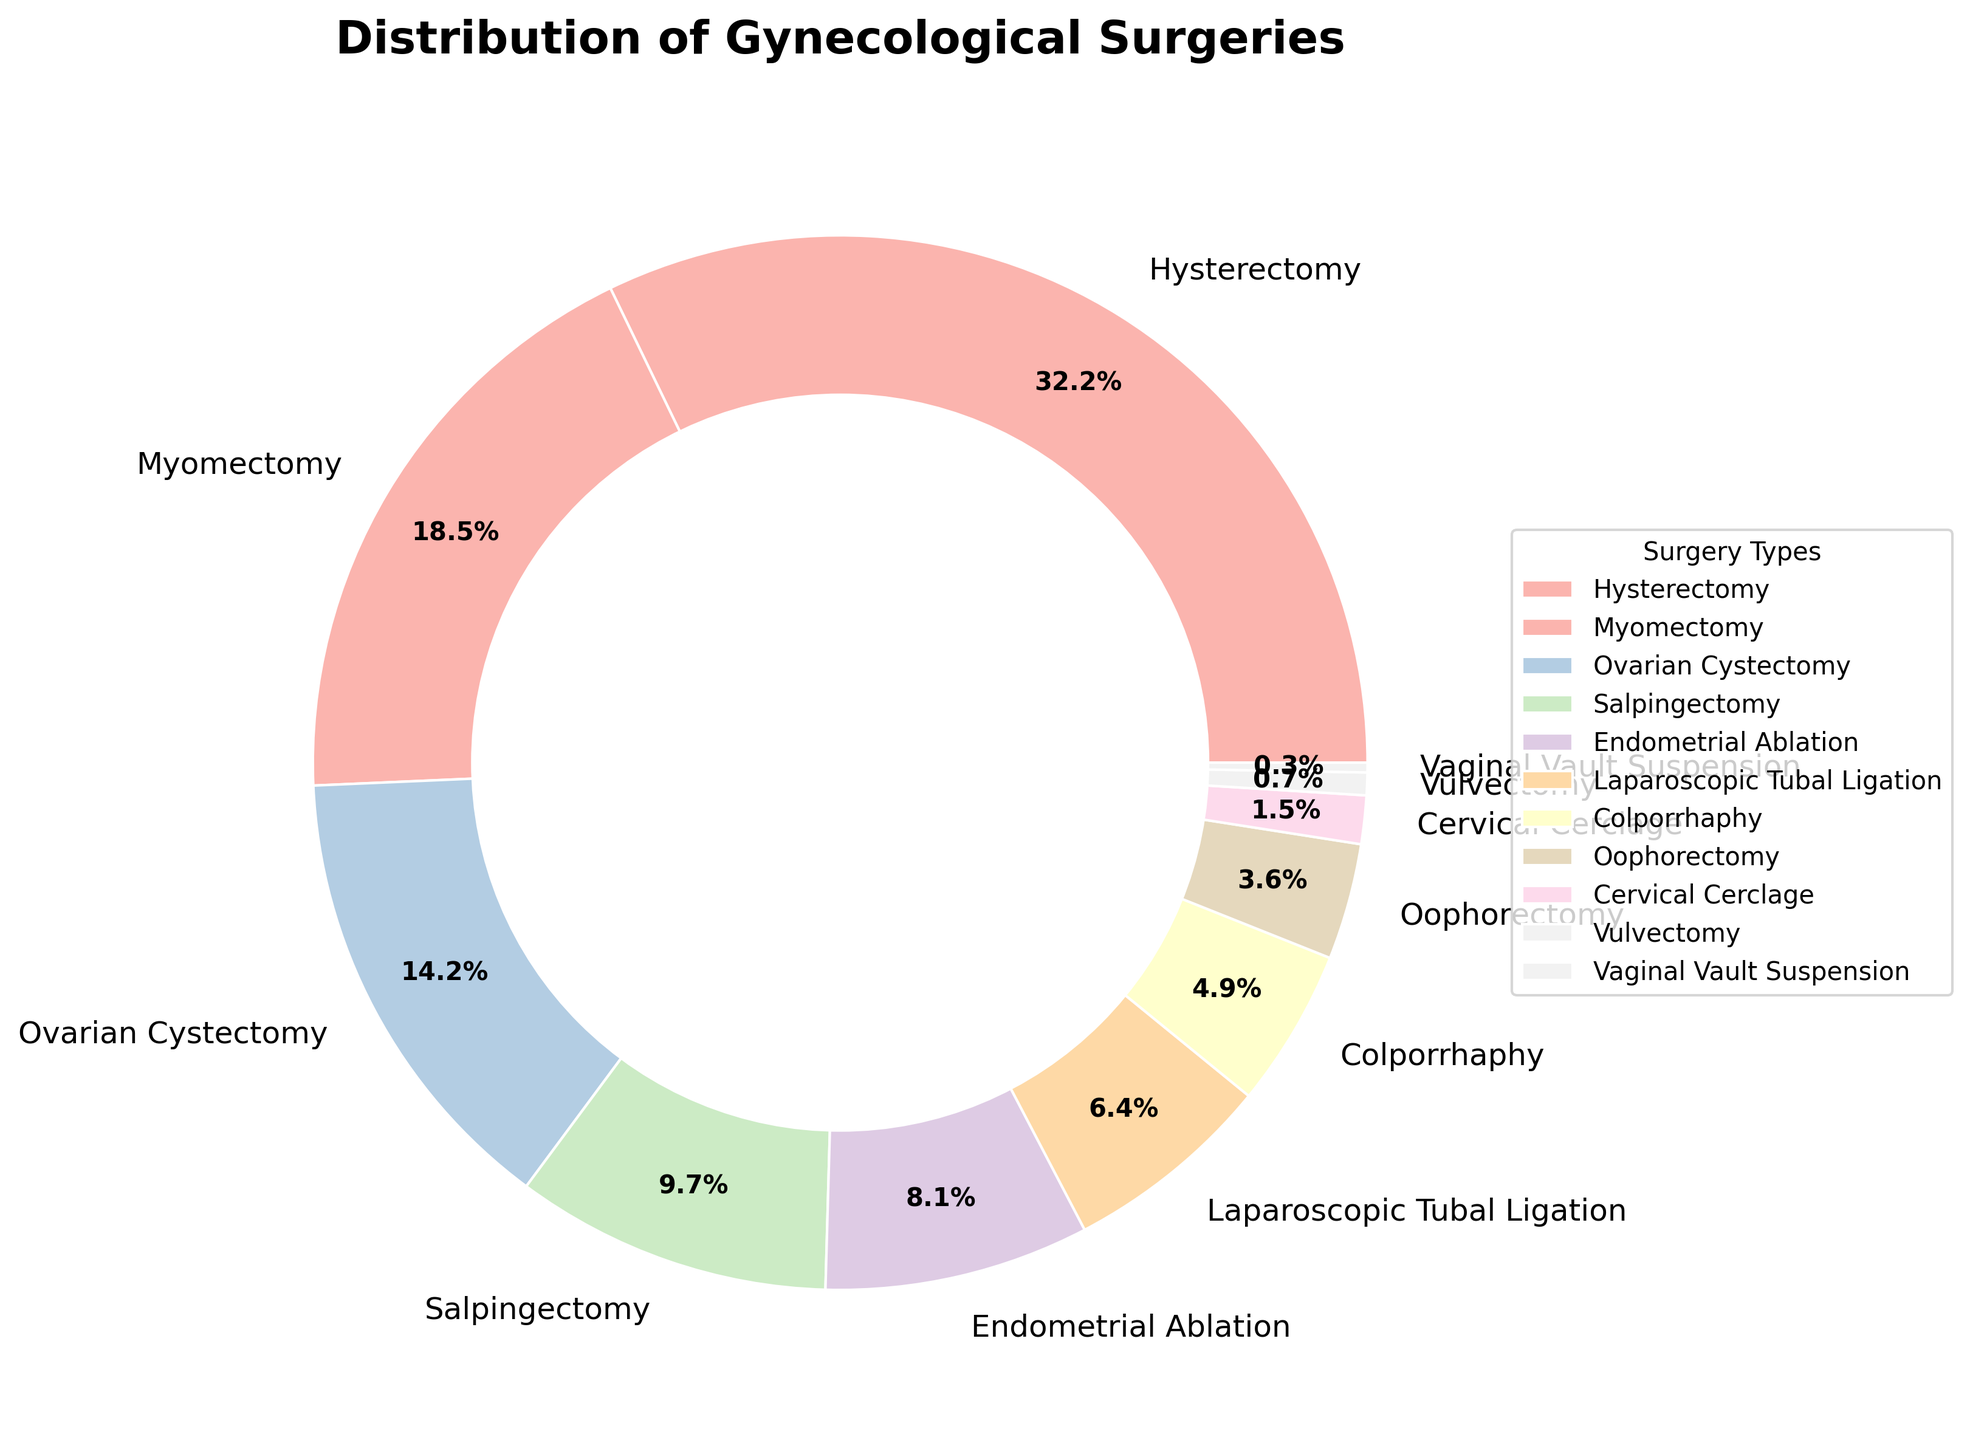Which surgery type constitutes the highest percentage? The pie chart shows different types of surgeries, each with a certain percentage of the total. The largest segment is Hysterectomy with 32.5%.
Answer: Hysterectomy Which surgeries together make up more than 50% of the total? We need to sum the percentages of the surgeries in descending order until the sum exceeds 50%. Hysterectomy (32.5%) + Myomectomy (18.7%) = 51.2%.
Answer: Hysterectomy and Myomectomy How does the percentage of Endometrial Ablation compare to that of Laparoscopic Tubal Ligation? Look at the corresponding segments in the pie chart. Endometrial Ablation is 8.2%, while Laparoscopic Tubal Ligation is 6.5%. 8.2% is greater than 6.5%.
Answer: Endometrial Ablation is greater What is the combined percentage of the three least performed surgeries? Add the percentages of Cervical Cerclage (1.5%), Vulvectomy (0.7%), and Vaginal Vault Suspension (0.3%): 1.5 + 0.7 + 0.3 = 2.5.
Answer: 2.5% If the combined percentage of Ovarian Cystectomy and Salpingectomy is compared to that of Hysterectomy, which one is greater? Add the percentages of Ovarian Cystectomy (14.3%) and Salpingectomy (9.8%): 14.3 + 9.8 = 24.1%. Compare this sum to Hysterectomy (32.5%). 32.5% is greater than 24.1%.
Answer: Hysterectomy is greater What is the total percentage represented by surgeries other than Hysterectomy and Myomectomy? Subtract the sum of Hysterectomy (32.5%) and Myomectomy (18.7%) from 100%: 100 - (32.5 + 18.7) = 48.8.
Answer: 48.8% Which surgery types constitute less than 10% each? Identify segments with less than 10%. These are Ovarian Cystectomy (14.3%) - Exceeds 10%, Salpingectomy (9.8%), Endometrial Ablation (8.2%), Laparoscopic Tubal Ligation (6.5%), Colporrhaphy (4.9%), Oophorectomy (3.6%), Cervical Cerclage (1.5%), Vulvectomy (0.7%), and Vaginal Vault Suspension (0.3%).
Answer: Salpingectomy, Endometrial Ablation, Laparoscopic Tubal Ligation, Colporrhaphy, Oophorectomy, Cervical Cerclage, Vulvectomy, Vaginal Vault Suspension 